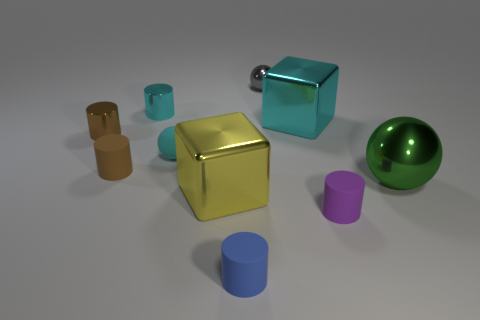Subtract all cyan spheres. How many spheres are left? 2 Subtract 2 cylinders. How many cylinders are left? 3 Subtract all green spheres. How many spheres are left? 2 Subtract all blocks. How many objects are left? 8 Subtract all tiny brown metallic objects. Subtract all big metallic cubes. How many objects are left? 7 Add 7 small balls. How many small balls are left? 9 Add 7 tiny rubber balls. How many tiny rubber balls exist? 8 Subtract 0 yellow spheres. How many objects are left? 10 Subtract all blue cylinders. Subtract all red blocks. How many cylinders are left? 4 Subtract all green spheres. How many yellow cylinders are left? 0 